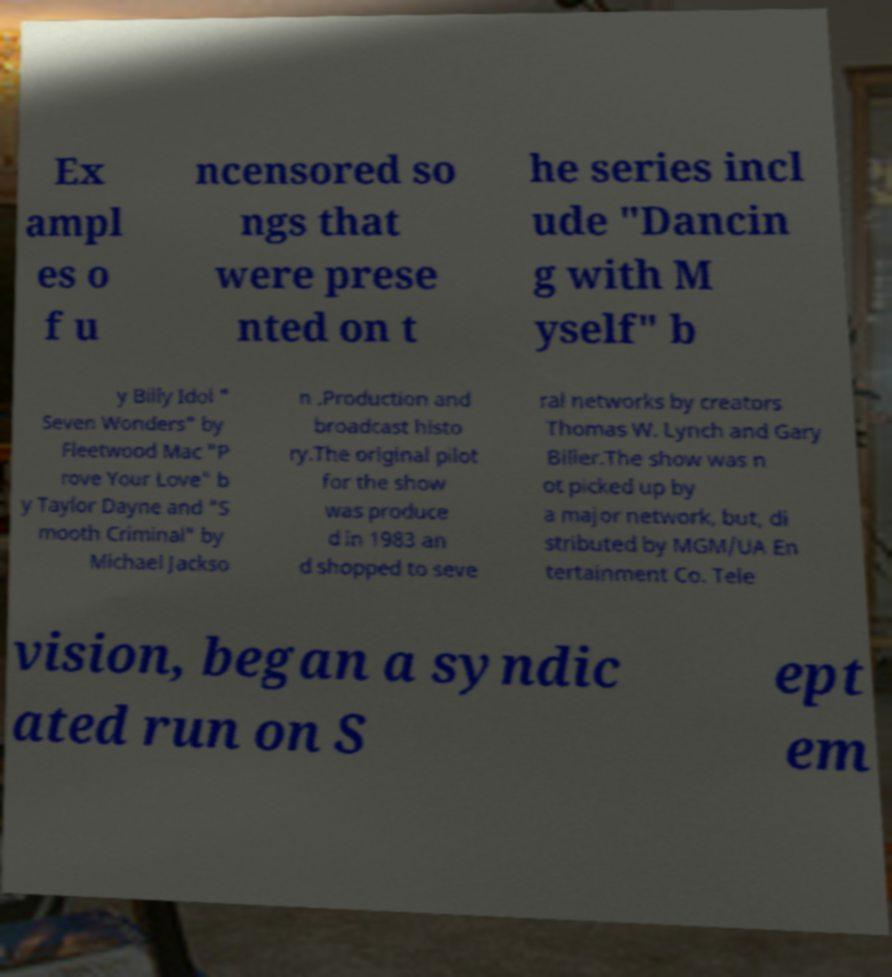For documentation purposes, I need the text within this image transcribed. Could you provide that? Ex ampl es o f u ncensored so ngs that were prese nted on t he series incl ude "Dancin g with M yself" b y Billy Idol " Seven Wonders" by Fleetwood Mac "P rove Your Love" b y Taylor Dayne and "S mooth Criminal" by Michael Jackso n .Production and broadcast histo ry.The original pilot for the show was produce d in 1983 an d shopped to seve ral networks by creators Thomas W. Lynch and Gary Biller.The show was n ot picked up by a major network, but, di stributed by MGM/UA En tertainment Co. Tele vision, began a syndic ated run on S ept em 